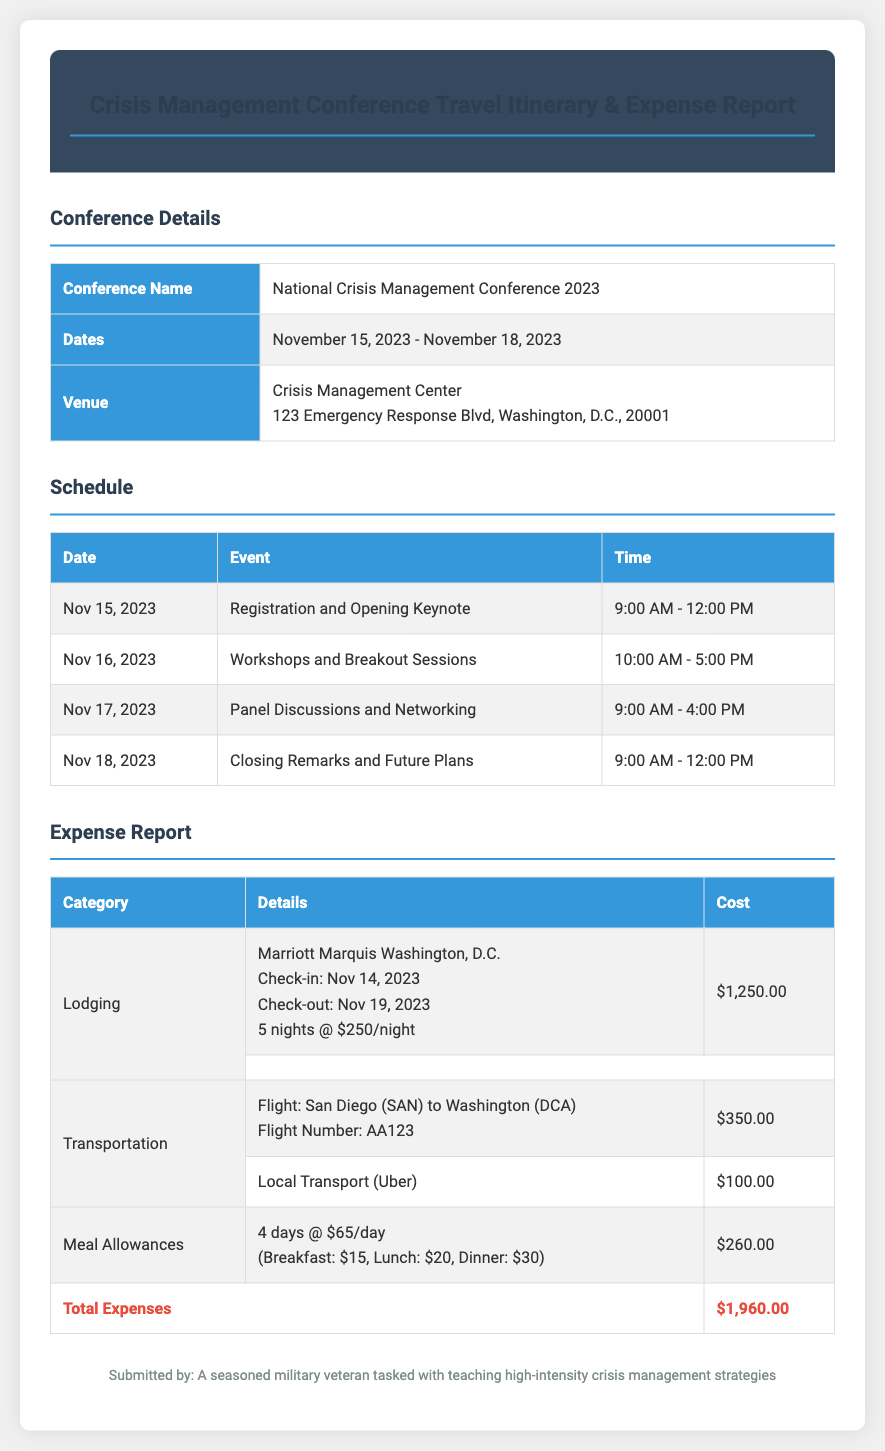What are the dates of the conference? The dates for the conference are stated in the document, which are November 15, 2023 - November 18, 2023.
Answer: November 15, 2023 - November 18, 2023 What is the total lodging cost? The total lodging cost is calculated from the details of the lodging section, which sums up to $1,250.00 for 5 nights at $250 per night.
Answer: $1,250.00 How many days of meal allowances are listed? The document states that there are 4 days of meal allowances included in the expense report.
Answer: 4 days What is the flight number for the transportation? The flight number is specified in the transportation section of the document as AA123.
Answer: AA123 What venue will the conference be held at? The venue information is provided in the conference details, which identifies the Crisis Management Center as the location.
Answer: Crisis Management Center What is the total reported cost for the trip? The total expenses are outlined at the bottom of the expense report, totaling $1,960.00.
Answer: $1,960.00 What event occurs on November 17, 2023? The schedule lists "Panel Discussions and Networking" as the event taking place on this date.
Answer: Panel Discussions and Networking What is the cost of local transport? The local transport cost, mentioned in the transportation section, is $100.00.
Answer: $100.00 